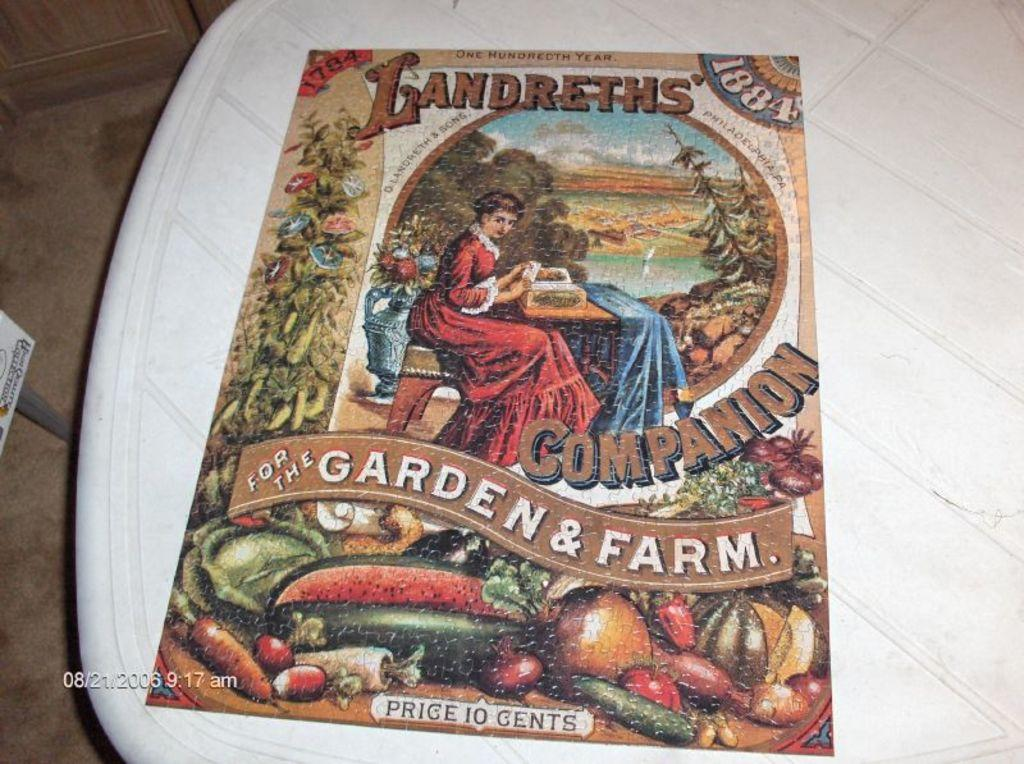Provide a one-sentence caption for the provided image. The front cover of an 1884 book about gardening that cost ten cents at the time of publication. 